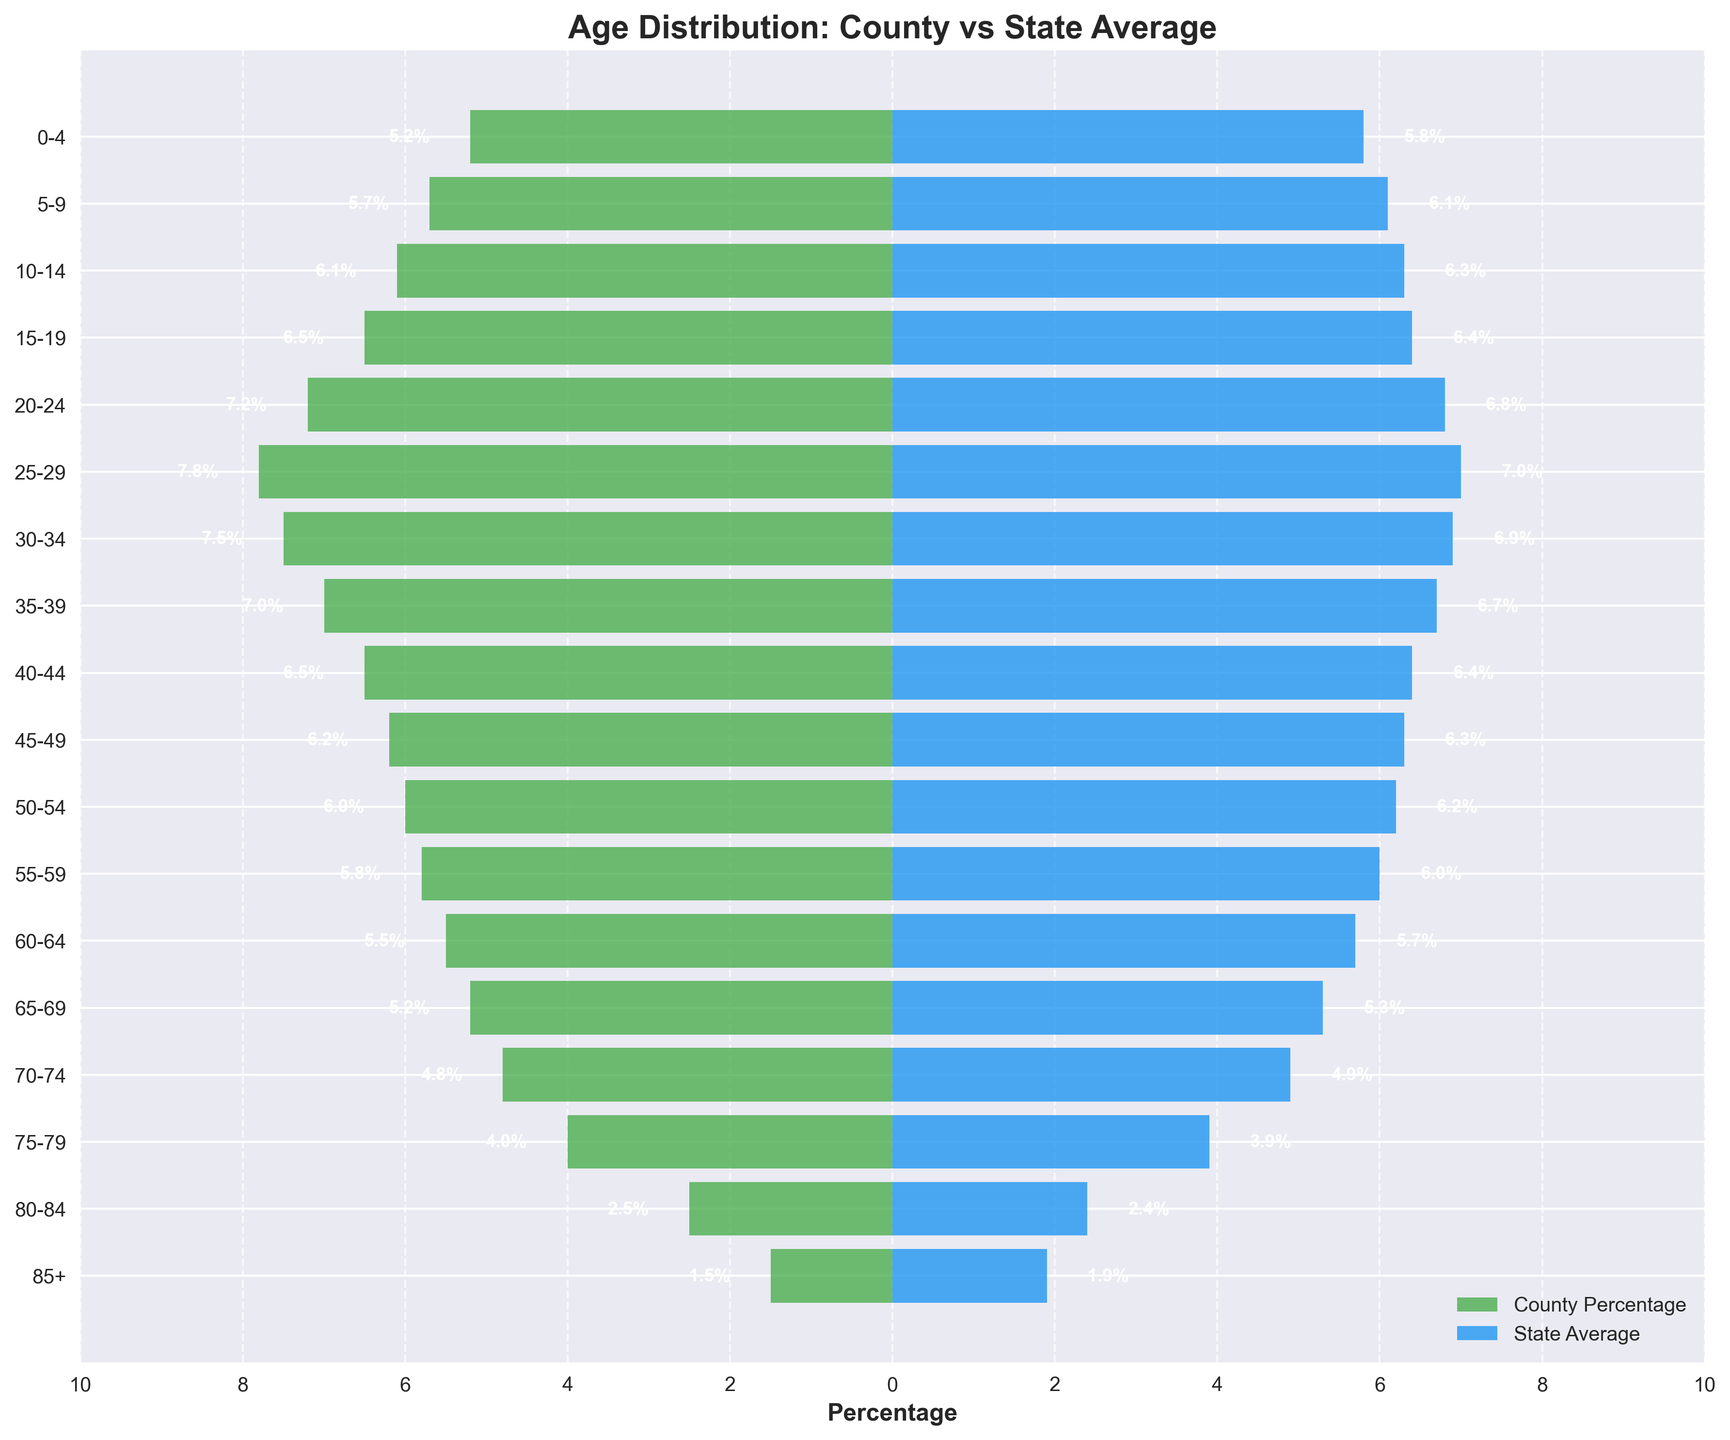Is the percentage of county residents aged 25-29 higher than the state average? Compare the percentage of the county residents aged 25-29 (7.8) with the state average (7.0). 7.8 is greater than 7.0
Answer: Yes Which age group has the greatest difference in percentage between the county and state averages? Calculate the differences for each age group: 0-4 (0.6), 5-9 (0.4), 10-14 (0.2), 15-19 (0.1), 20-24 (0.4), 25-29 (0.8), 30-34 (0.6), 35-39 (0.3), 40-44 (0.1), 45-49 (0.1), 50-54 (0.2), 55-59 (0.2), 60-64 (0.2), 65-69 (0.1), 70-74 (0.1), 75-79 (0.1), 80-84 (0.1), 85+ (0.4). Age group 25-29 has the greatest difference of 0.8
Answer: 25-29 What is the title of the plot? The title can be found at the top of the plot. It reads "Age Distribution: County vs State Average"
Answer: Age Distribution: County vs State Average For which age group is the county percentage lower than the state average? Compare the county percentage and state average for each age group. The age groups where the county percentage is lower are 0-4, 5-9, 10-14, 55-59, 60-64, 65-69, 70-74, and 85+
Answer: 0-4, 5-9, 10-14, 55-59, 60-64, 65-69, 70-74, 85+ What's the percentage difference between the county and state averages for the 85+ age group? Find the percentages for the 85+ age group: county (1.5) and state average (1.9). Calculate the difference: \( 1.9 - 1.5 = 0.4 \)
Answer: 0.4 Which age group has the highest county percentage? Identify the county percentages for each age group. The highest county percentage is for the age group 25-29 at 7.8
Answer: 25-29 What colors represent the county percentage and state average bars? Determine the colors from the plot. The county percentage bars are green, and the state average bars are blue
Answer: Green and Blue In which age group is the county percentage exactly equal to the state average? Compare county and state percentages for each age group. For age group 15-19, both have percentages 6.4
Answer: 15-19 What is the range of the x-axis in the plot? Read the x-axis limits on the plot. The range extends from -10 to 10
Answer: -10 to 10 